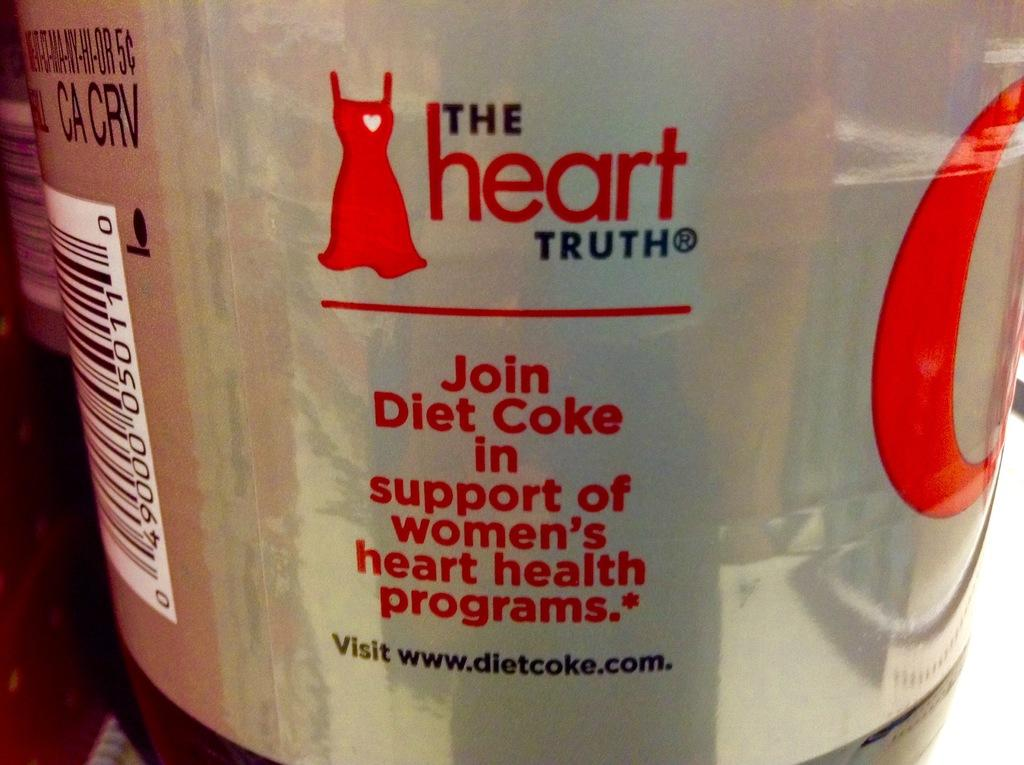<image>
Relay a brief, clear account of the picture shown. a diet coke bottle labeled 'the heart truth' on the side 